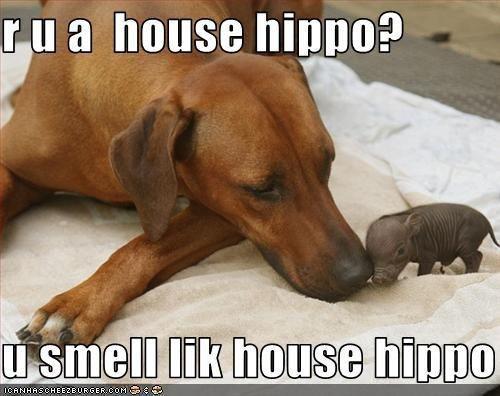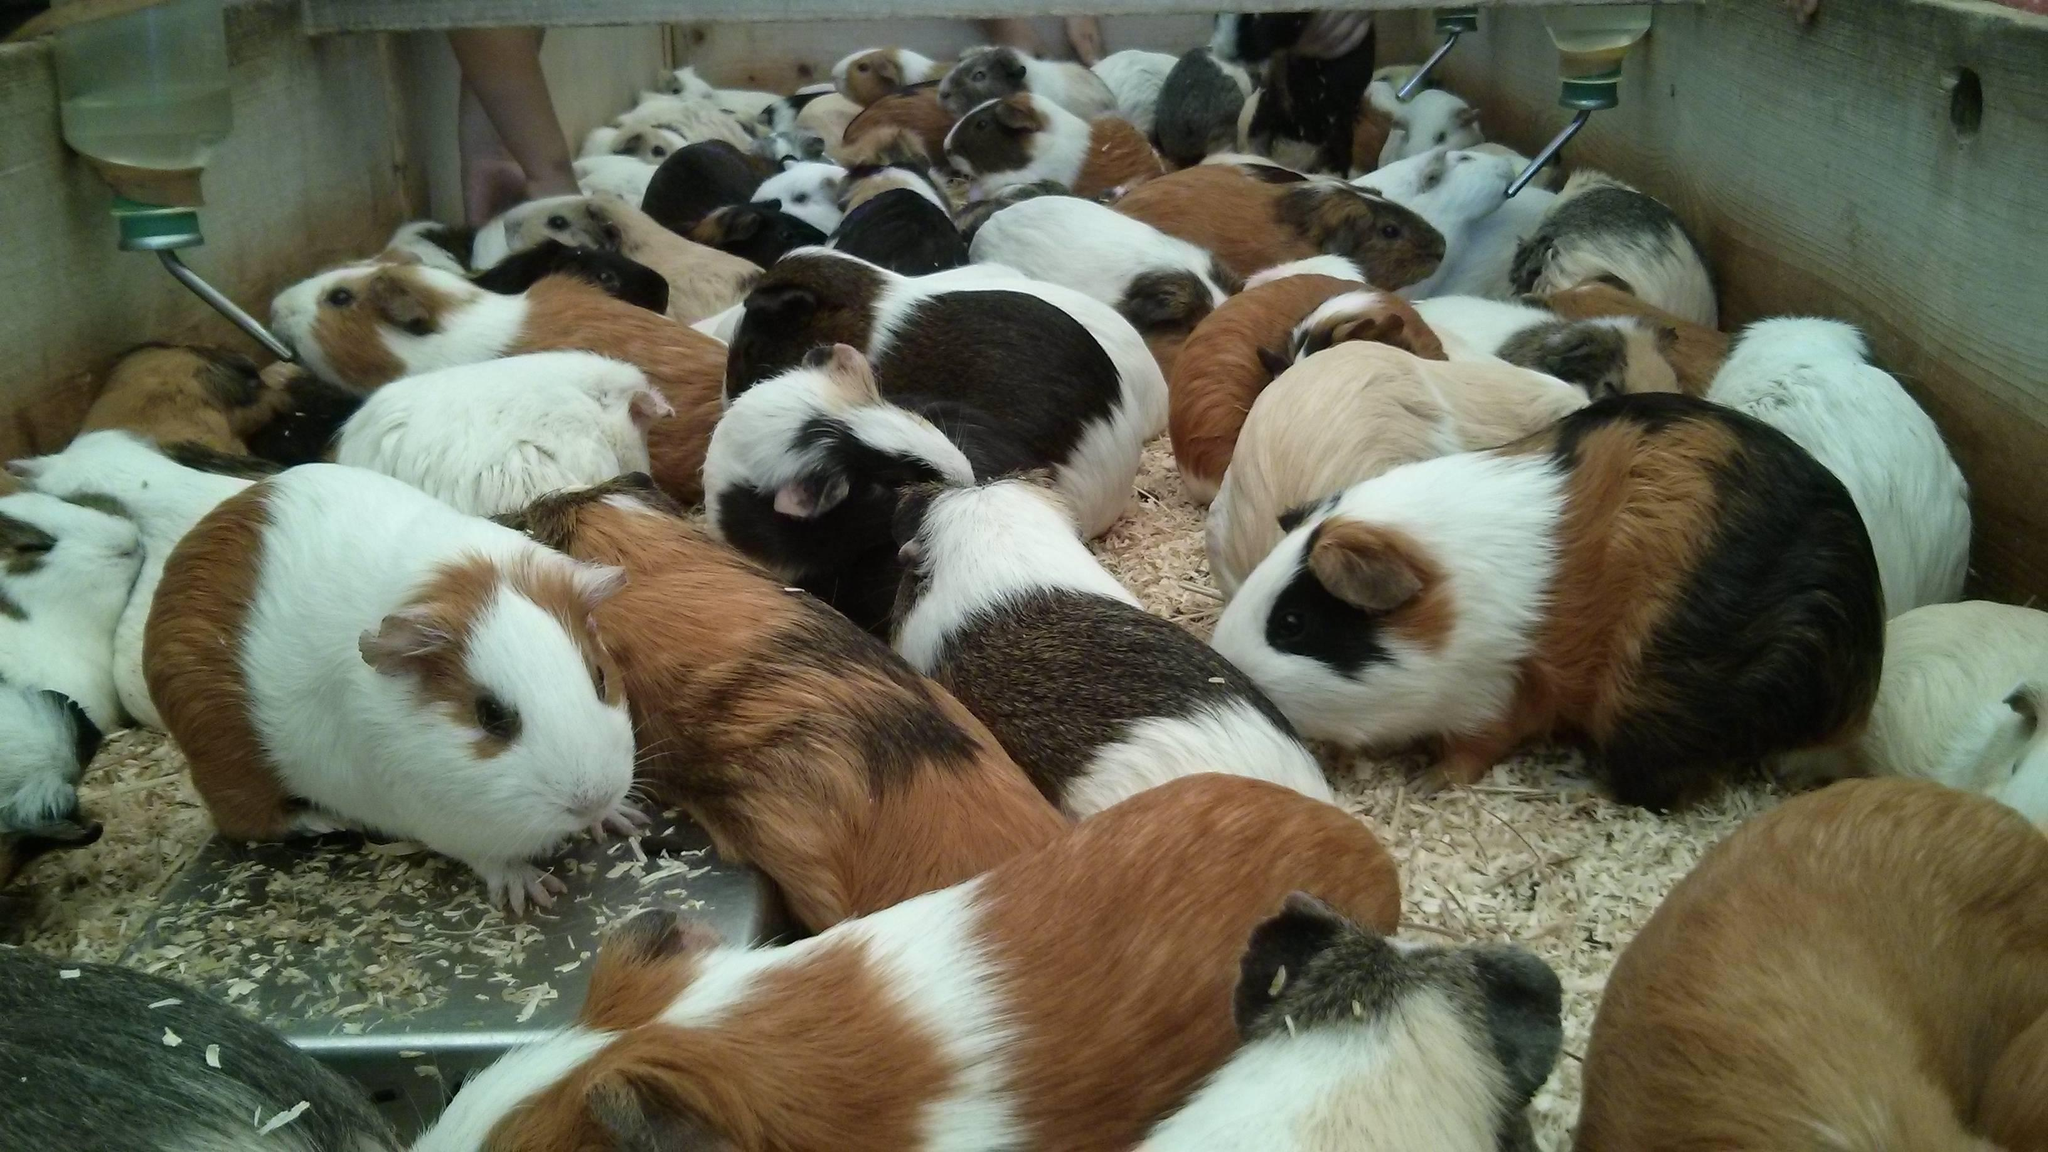The first image is the image on the left, the second image is the image on the right. For the images shown, is this caption "An image shows exactly four guinea pigs in a horizontal row." true? Answer yes or no. No. The first image is the image on the left, the second image is the image on the right. For the images shown, is this caption "Four rodents sit in a row in one of the images." true? Answer yes or no. No. 